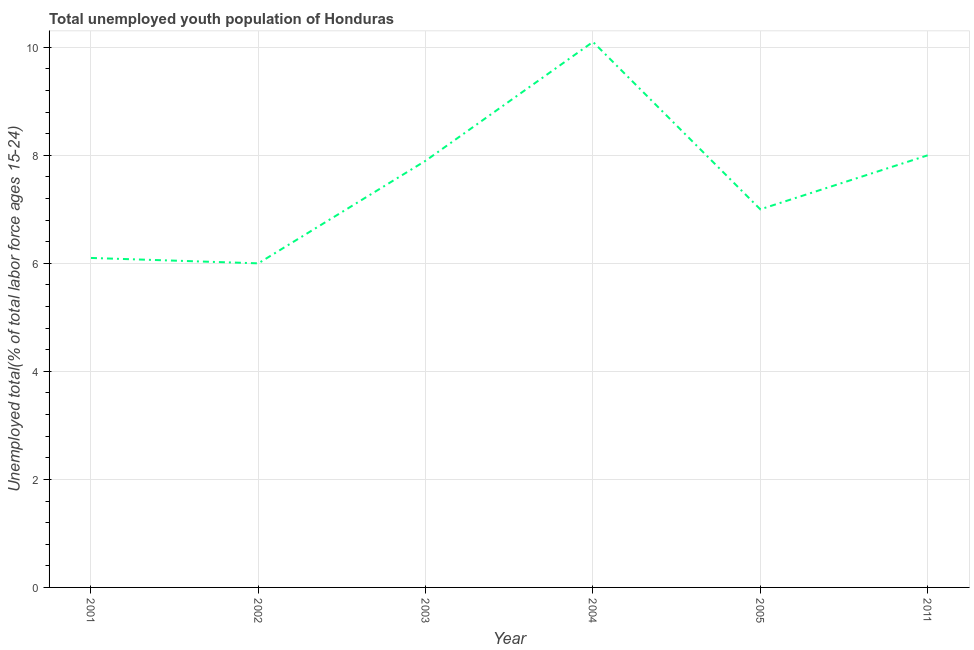What is the unemployed youth in 2004?
Ensure brevity in your answer.  10.1. Across all years, what is the maximum unemployed youth?
Provide a short and direct response. 10.1. In which year was the unemployed youth maximum?
Keep it short and to the point. 2004. In which year was the unemployed youth minimum?
Ensure brevity in your answer.  2002. What is the sum of the unemployed youth?
Make the answer very short. 45.1. What is the difference between the unemployed youth in 2001 and 2004?
Give a very brief answer. -4. What is the average unemployed youth per year?
Ensure brevity in your answer.  7.52. What is the median unemployed youth?
Your answer should be compact. 7.45. Do a majority of the years between 2001 and 2011 (inclusive) have unemployed youth greater than 9.2 %?
Make the answer very short. No. What is the ratio of the unemployed youth in 2001 to that in 2002?
Ensure brevity in your answer.  1.02. Is the unemployed youth in 2004 less than that in 2005?
Give a very brief answer. No. What is the difference between the highest and the second highest unemployed youth?
Offer a terse response. 2.1. What is the difference between the highest and the lowest unemployed youth?
Your answer should be very brief. 4.1. How many years are there in the graph?
Your response must be concise. 6. Are the values on the major ticks of Y-axis written in scientific E-notation?
Give a very brief answer. No. Does the graph contain grids?
Offer a very short reply. Yes. What is the title of the graph?
Ensure brevity in your answer.  Total unemployed youth population of Honduras. What is the label or title of the X-axis?
Provide a succinct answer. Year. What is the label or title of the Y-axis?
Keep it short and to the point. Unemployed total(% of total labor force ages 15-24). What is the Unemployed total(% of total labor force ages 15-24) of 2001?
Provide a succinct answer. 6.1. What is the Unemployed total(% of total labor force ages 15-24) in 2003?
Your response must be concise. 7.9. What is the Unemployed total(% of total labor force ages 15-24) of 2004?
Provide a succinct answer. 10.1. What is the Unemployed total(% of total labor force ages 15-24) of 2005?
Make the answer very short. 7. What is the Unemployed total(% of total labor force ages 15-24) of 2011?
Offer a terse response. 8. What is the difference between the Unemployed total(% of total labor force ages 15-24) in 2001 and 2003?
Your answer should be very brief. -1.8. What is the difference between the Unemployed total(% of total labor force ages 15-24) in 2001 and 2004?
Keep it short and to the point. -4. What is the difference between the Unemployed total(% of total labor force ages 15-24) in 2001 and 2005?
Ensure brevity in your answer.  -0.9. What is the difference between the Unemployed total(% of total labor force ages 15-24) in 2001 and 2011?
Your answer should be very brief. -1.9. What is the difference between the Unemployed total(% of total labor force ages 15-24) in 2002 and 2011?
Provide a succinct answer. -2. What is the difference between the Unemployed total(% of total labor force ages 15-24) in 2003 and 2005?
Ensure brevity in your answer.  0.9. What is the difference between the Unemployed total(% of total labor force ages 15-24) in 2004 and 2005?
Make the answer very short. 3.1. What is the difference between the Unemployed total(% of total labor force ages 15-24) in 2005 and 2011?
Give a very brief answer. -1. What is the ratio of the Unemployed total(% of total labor force ages 15-24) in 2001 to that in 2002?
Provide a succinct answer. 1.02. What is the ratio of the Unemployed total(% of total labor force ages 15-24) in 2001 to that in 2003?
Your answer should be compact. 0.77. What is the ratio of the Unemployed total(% of total labor force ages 15-24) in 2001 to that in 2004?
Ensure brevity in your answer.  0.6. What is the ratio of the Unemployed total(% of total labor force ages 15-24) in 2001 to that in 2005?
Provide a short and direct response. 0.87. What is the ratio of the Unemployed total(% of total labor force ages 15-24) in 2001 to that in 2011?
Your answer should be very brief. 0.76. What is the ratio of the Unemployed total(% of total labor force ages 15-24) in 2002 to that in 2003?
Provide a succinct answer. 0.76. What is the ratio of the Unemployed total(% of total labor force ages 15-24) in 2002 to that in 2004?
Keep it short and to the point. 0.59. What is the ratio of the Unemployed total(% of total labor force ages 15-24) in 2002 to that in 2005?
Give a very brief answer. 0.86. What is the ratio of the Unemployed total(% of total labor force ages 15-24) in 2002 to that in 2011?
Keep it short and to the point. 0.75. What is the ratio of the Unemployed total(% of total labor force ages 15-24) in 2003 to that in 2004?
Your answer should be very brief. 0.78. What is the ratio of the Unemployed total(% of total labor force ages 15-24) in 2003 to that in 2005?
Provide a succinct answer. 1.13. What is the ratio of the Unemployed total(% of total labor force ages 15-24) in 2003 to that in 2011?
Offer a very short reply. 0.99. What is the ratio of the Unemployed total(% of total labor force ages 15-24) in 2004 to that in 2005?
Offer a very short reply. 1.44. What is the ratio of the Unemployed total(% of total labor force ages 15-24) in 2004 to that in 2011?
Your response must be concise. 1.26. What is the ratio of the Unemployed total(% of total labor force ages 15-24) in 2005 to that in 2011?
Ensure brevity in your answer.  0.88. 